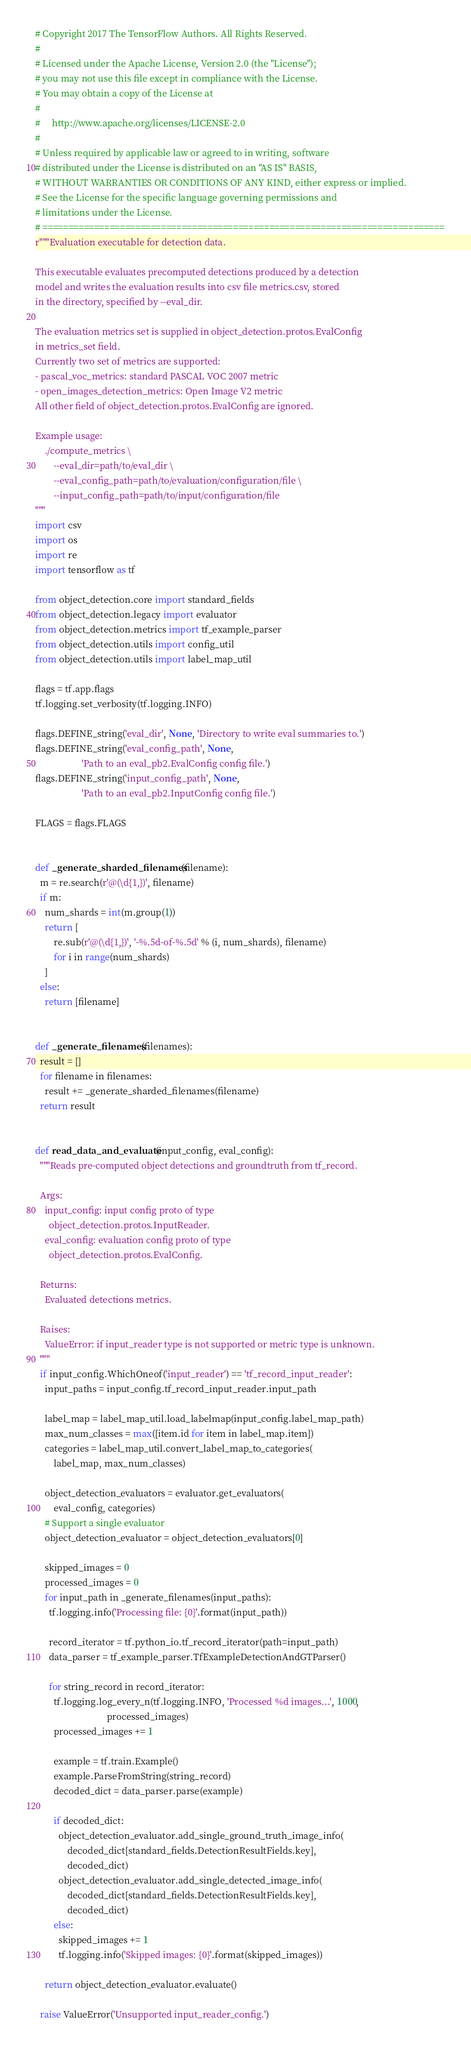Convert code to text. <code><loc_0><loc_0><loc_500><loc_500><_Python_># Copyright 2017 The TensorFlow Authors. All Rights Reserved.
#
# Licensed under the Apache License, Version 2.0 (the "License");
# you may not use this file except in compliance with the License.
# You may obtain a copy of the License at
#
#     http://www.apache.org/licenses/LICENSE-2.0
#
# Unless required by applicable law or agreed to in writing, software
# distributed under the License is distributed on an "AS IS" BASIS,
# WITHOUT WARRANTIES OR CONDITIONS OF ANY KIND, either express or implied.
# See the License for the specific language governing permissions and
# limitations under the License.
# ==============================================================================
r"""Evaluation executable for detection data.

This executable evaluates precomputed detections produced by a detection
model and writes the evaluation results into csv file metrics.csv, stored
in the directory, specified by --eval_dir.

The evaluation metrics set is supplied in object_detection.protos.EvalConfig
in metrics_set field.
Currently two set of metrics are supported:
- pascal_voc_metrics: standard PASCAL VOC 2007 metric
- open_images_detection_metrics: Open Image V2 metric
All other field of object_detection.protos.EvalConfig are ignored.

Example usage:
    ./compute_metrics \
        --eval_dir=path/to/eval_dir \
        --eval_config_path=path/to/evaluation/configuration/file \
        --input_config_path=path/to/input/configuration/file
"""
import csv
import os
import re
import tensorflow as tf

from object_detection.core import standard_fields
from object_detection.legacy import evaluator
from object_detection.metrics import tf_example_parser
from object_detection.utils import config_util
from object_detection.utils import label_map_util

flags = tf.app.flags
tf.logging.set_verbosity(tf.logging.INFO)

flags.DEFINE_string('eval_dir', None, 'Directory to write eval summaries to.')
flags.DEFINE_string('eval_config_path', None,
                    'Path to an eval_pb2.EvalConfig config file.')
flags.DEFINE_string('input_config_path', None,
                    'Path to an eval_pb2.InputConfig config file.')

FLAGS = flags.FLAGS


def _generate_sharded_filenames(filename):
  m = re.search(r'@(\d{1,})', filename)
  if m:
    num_shards = int(m.group(1))
    return [
        re.sub(r'@(\d{1,})', '-%.5d-of-%.5d' % (i, num_shards), filename)
        for i in range(num_shards)
    ]
  else:
    return [filename]


def _generate_filenames(filenames):
  result = []
  for filename in filenames:
    result += _generate_sharded_filenames(filename)
  return result


def read_data_and_evaluate(input_config, eval_config):
  """Reads pre-computed object detections and groundtruth from tf_record.

  Args:
    input_config: input config proto of type
      object_detection.protos.InputReader.
    eval_config: evaluation config proto of type
      object_detection.protos.EvalConfig.

  Returns:
    Evaluated detections metrics.

  Raises:
    ValueError: if input_reader type is not supported or metric type is unknown.
  """
  if input_config.WhichOneof('input_reader') == 'tf_record_input_reader':
    input_paths = input_config.tf_record_input_reader.input_path

    label_map = label_map_util.load_labelmap(input_config.label_map_path)
    max_num_classes = max([item.id for item in label_map.item])
    categories = label_map_util.convert_label_map_to_categories(
        label_map, max_num_classes)

    object_detection_evaluators = evaluator.get_evaluators(
        eval_config, categories)
    # Support a single evaluator
    object_detection_evaluator = object_detection_evaluators[0]

    skipped_images = 0
    processed_images = 0
    for input_path in _generate_filenames(input_paths):
      tf.logging.info('Processing file: {0}'.format(input_path))

      record_iterator = tf.python_io.tf_record_iterator(path=input_path)
      data_parser = tf_example_parser.TfExampleDetectionAndGTParser()

      for string_record in record_iterator:
        tf.logging.log_every_n(tf.logging.INFO, 'Processed %d images...', 1000,
                               processed_images)
        processed_images += 1

        example = tf.train.Example()
        example.ParseFromString(string_record)
        decoded_dict = data_parser.parse(example)

        if decoded_dict:
          object_detection_evaluator.add_single_ground_truth_image_info(
              decoded_dict[standard_fields.DetectionResultFields.key],
              decoded_dict)
          object_detection_evaluator.add_single_detected_image_info(
              decoded_dict[standard_fields.DetectionResultFields.key],
              decoded_dict)
        else:
          skipped_images += 1
          tf.logging.info('Skipped images: {0}'.format(skipped_images))

    return object_detection_evaluator.evaluate()

  raise ValueError('Unsupported input_reader_config.')

</code> 